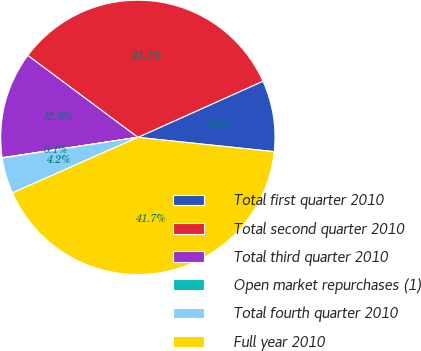<chart> <loc_0><loc_0><loc_500><loc_500><pie_chart><fcel>Total first quarter 2010<fcel>Total second quarter 2010<fcel>Total third quarter 2010<fcel>Open market repurchases (1)<fcel>Total fourth quarter 2010<fcel>Full year 2010<nl><fcel>8.38%<fcel>33.1%<fcel>12.55%<fcel>0.05%<fcel>4.22%<fcel>41.7%<nl></chart> 